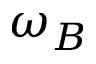<formula> <loc_0><loc_0><loc_500><loc_500>\omega _ { B }</formula> 